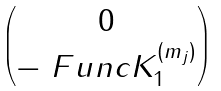Convert formula to latex. <formula><loc_0><loc_0><loc_500><loc_500>\begin{pmatrix} 0 \\ - \ F u n c { K } _ { 1 } ^ { ( m _ { j } ) } \end{pmatrix}</formula> 